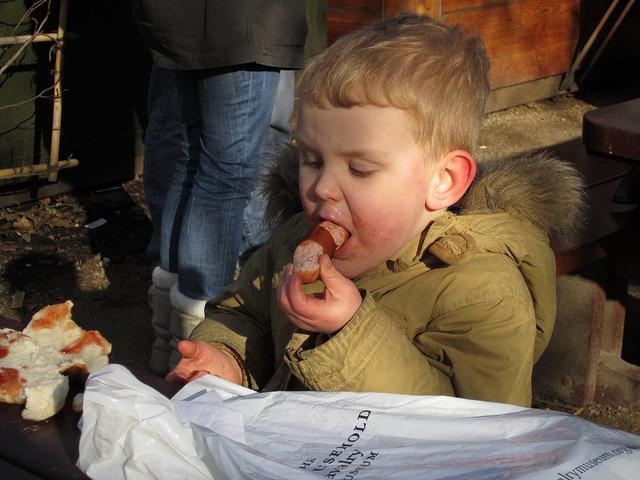Why is the food eaten by the boy unhealthy?
Select the accurate response from the four choices given to answer the question.
Options: High sodium, high carbohydrate, high fat, high sugar. High sodium. 